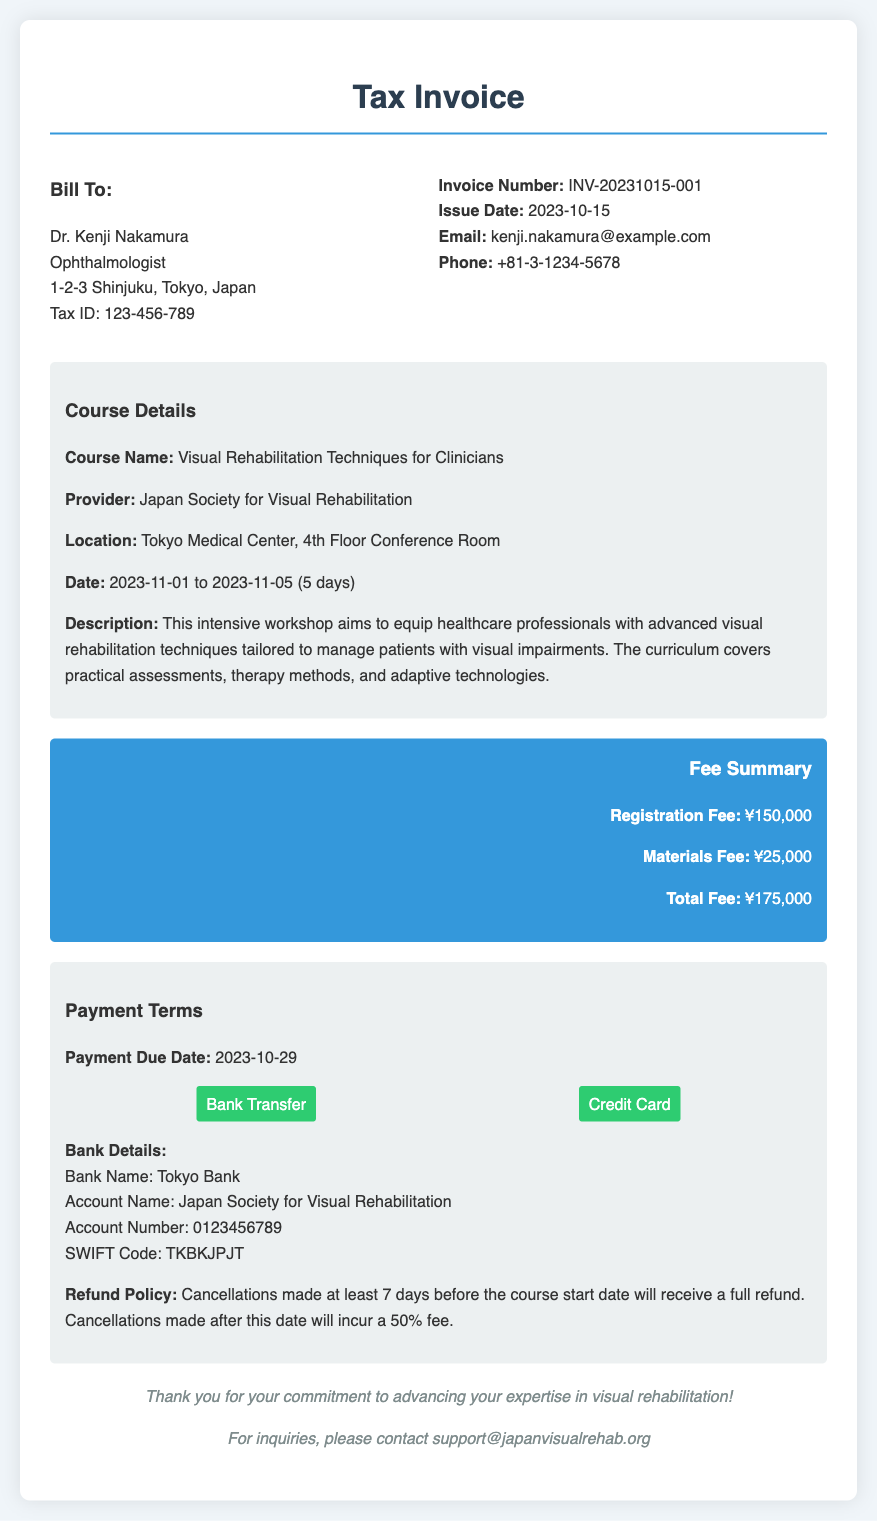What is the course name? The course name is provided in the course details section of the document.
Answer: Visual Rehabilitation Techniques for Clinicians What is the total fee? The total fee is summarized in the fee summary section of the document.
Answer: ¥175,000 What is the payment due date? The payment due date is mentioned in the payment terms section of the document.
Answer: 2023-10-29 Who is the provider of the course? The provider name can be found in the course details section of the document.
Answer: Japan Society for Visual Rehabilitation What is the registration fee? The registration fee is listed in the fee summary of the document.
Answer: ¥150,000 How many days does the course last? The duration of the course is detailed in the course details section.
Answer: 5 days What is the refund policy for cancellations? The refund policy is specified in the payment terms section of the document.
Answer: Cancellations made at least 7 days before the course start date will receive a full refund What is the description of the course? The course description is outlined in the course details section and includes the objectives and content.
Answer: This intensive workshop aims to equip healthcare professionals with advanced visual rehabilitation techniques tailored to manage patients with visual impairments Which bank should payments be made to? The bank information is included in the payment terms section of the document.
Answer: Tokyo Bank 